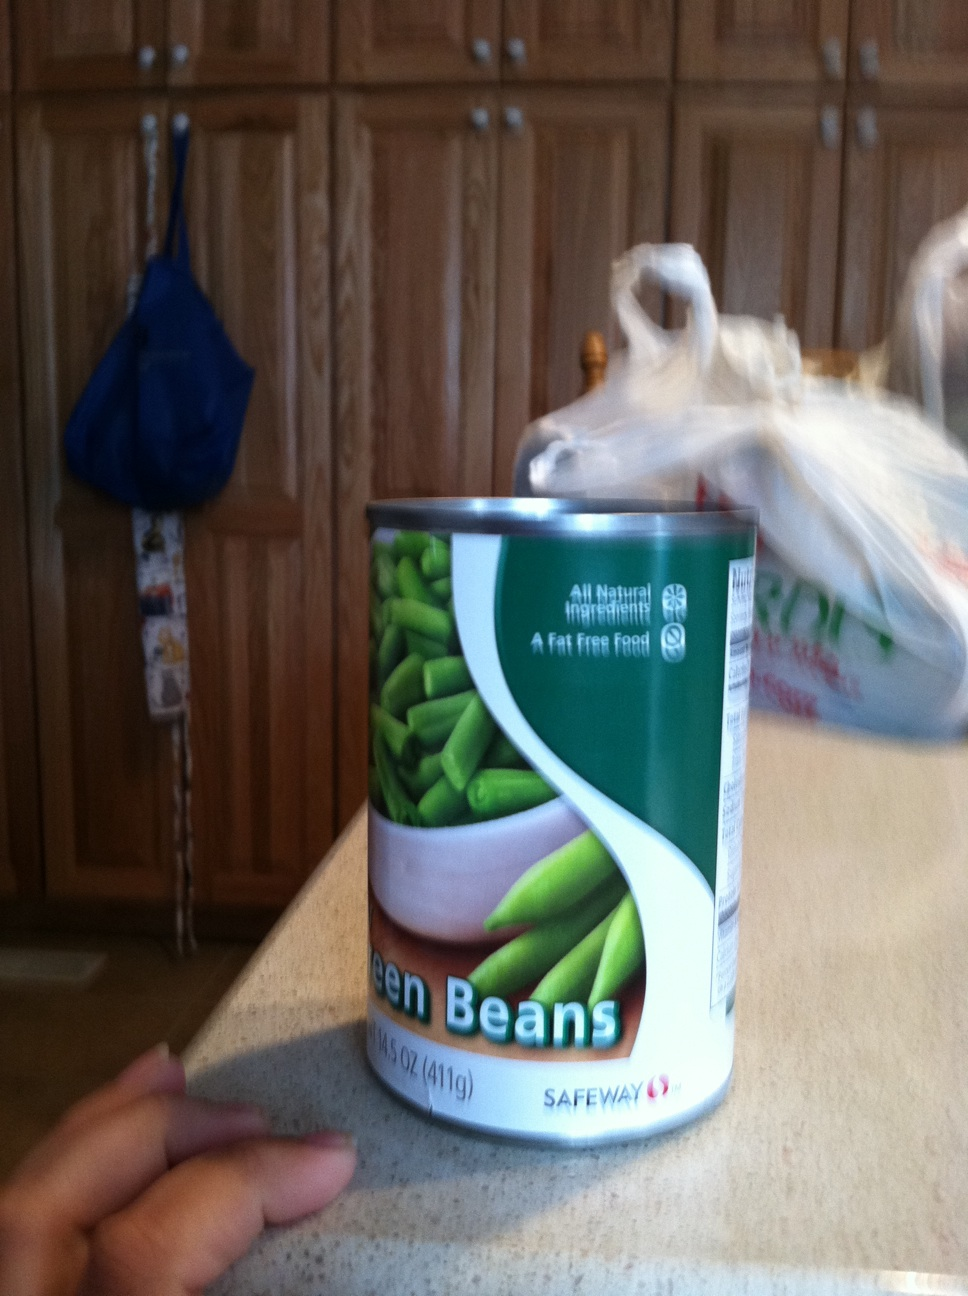Can you tell me more about the nutritional benefits of green beans? Certainly! Green beans are low in calories and fat but high in fiber. They provide a good source of protein, iron, and vitamins, particularly vitamin C and vitamin K. 